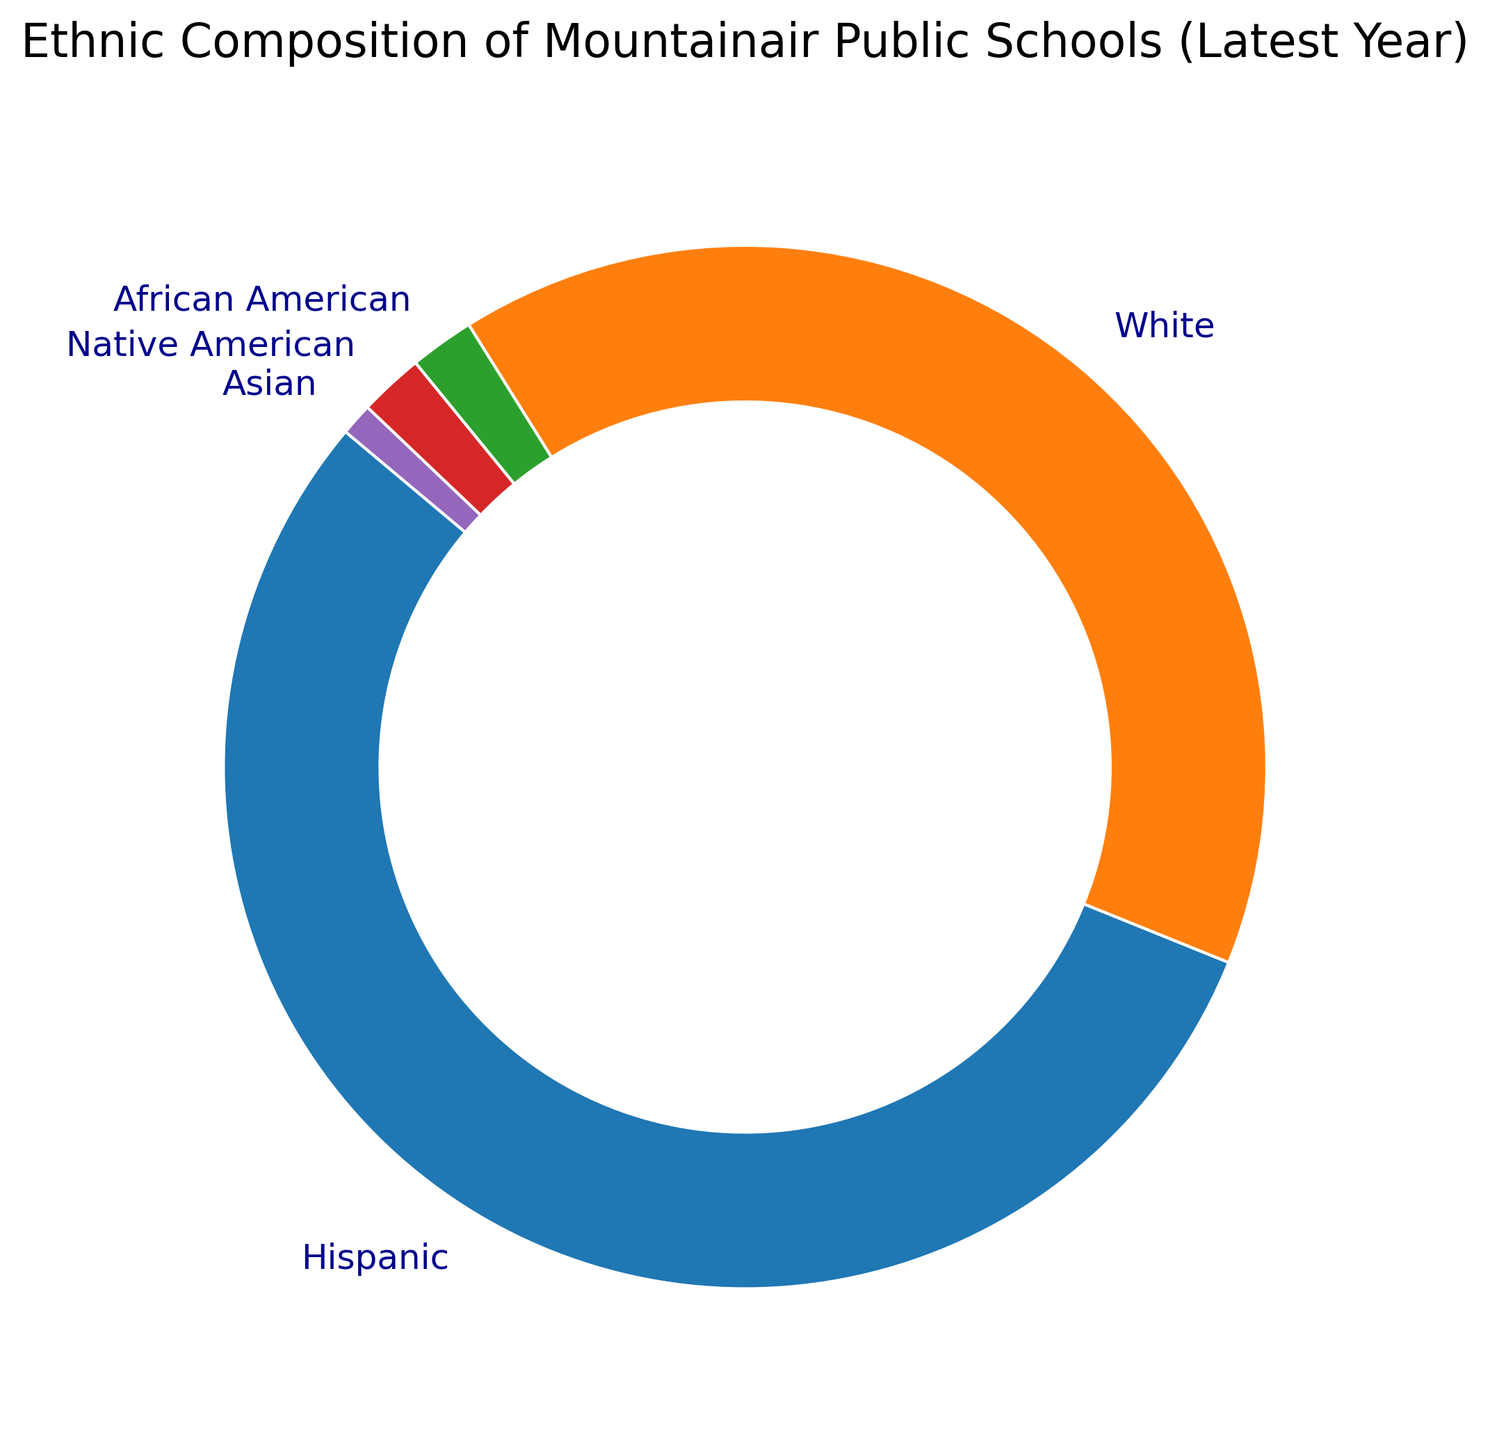What is the percentage of Hispanic students in the latest year? The ring chart clearly displays the percentage of Hispanic students, marked by a label "Hispanic" and the percentage value "55%".
Answer: 55% How many ethnicity groups have a percentage value greater than 2%? By looking at the ring chart, the ethnicity groups with percentages greater than 2% are Hispanic (55%) and White (40%). Only these two groups have percentages greater than 2%.
Answer: 2 Which ethnic group has the smallest representation in the latest year? The ring chart shows the ethnic group percentages. Asian students have the smallest representation with 1%.
Answer: Asian What is the combined percentage of African American and Native American students? From the ring chart, African American students have 2% and Native American students have 2%. Adding these values gives 2% + 2% = 4%.
Answer: 4% How does the percentage of White students compare to the combined percentage of African American, Native American, and Asian students? The percentage of White students is 40%. Adding the percentages for African American (2%), Native American (2%), and Asian (1%) gives 5%. So, the percentage of White students is 40% compared to the combined 5%.
Answer: White students: 40%, Combined: 5% What is the difference in percentage between Hispanic and White students? The chart shows Hispanic students at 55% and White students at 40%. The difference would be 55% - 40% = 15%.
Answer: 15% If you combine the percentages of all non-Hispanic ethnic groups, what do you get? The non-Hispanic groups are White (40%), African American (2%), Native American (2%), and Asian (1%). Adding these: 40% + 2% + 2% + 1% = 45%.
Answer: 45% Which ethnic groups have the same percentage value? The ring chart shows that both African American and Native American students have the same percentage value of 2%.
Answer: African American and Native American What is the visual difference between the sections represented by Hispanic and Asian students? The Hispanic section is significantly larger and covers more of the ring, while the Asian section is quite small and takes up a minimal portion. This visually represents the difference in their percentage values (55% vs 1%).
Answer: Hispanic is larger than Asian What can you infer about the diversity in Mountainair public schools? The ring chart indicates that the school composition is predominantly Hispanic (55%) and White (40%), with African American, Native American, and Asian students making up a small proportion (each under 3%).
Answer: Predominantly Hispanic and White, low diversity in other groups 